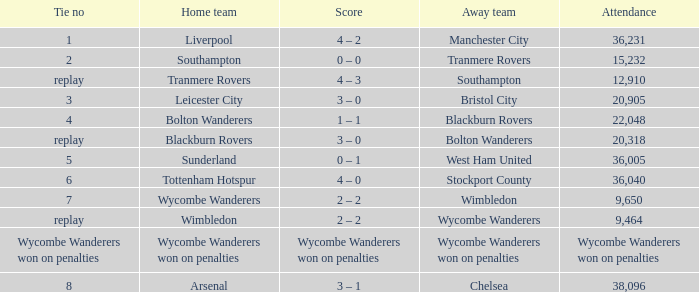What was the name of the guest team that had a tie of 2? Tranmere Rovers. 